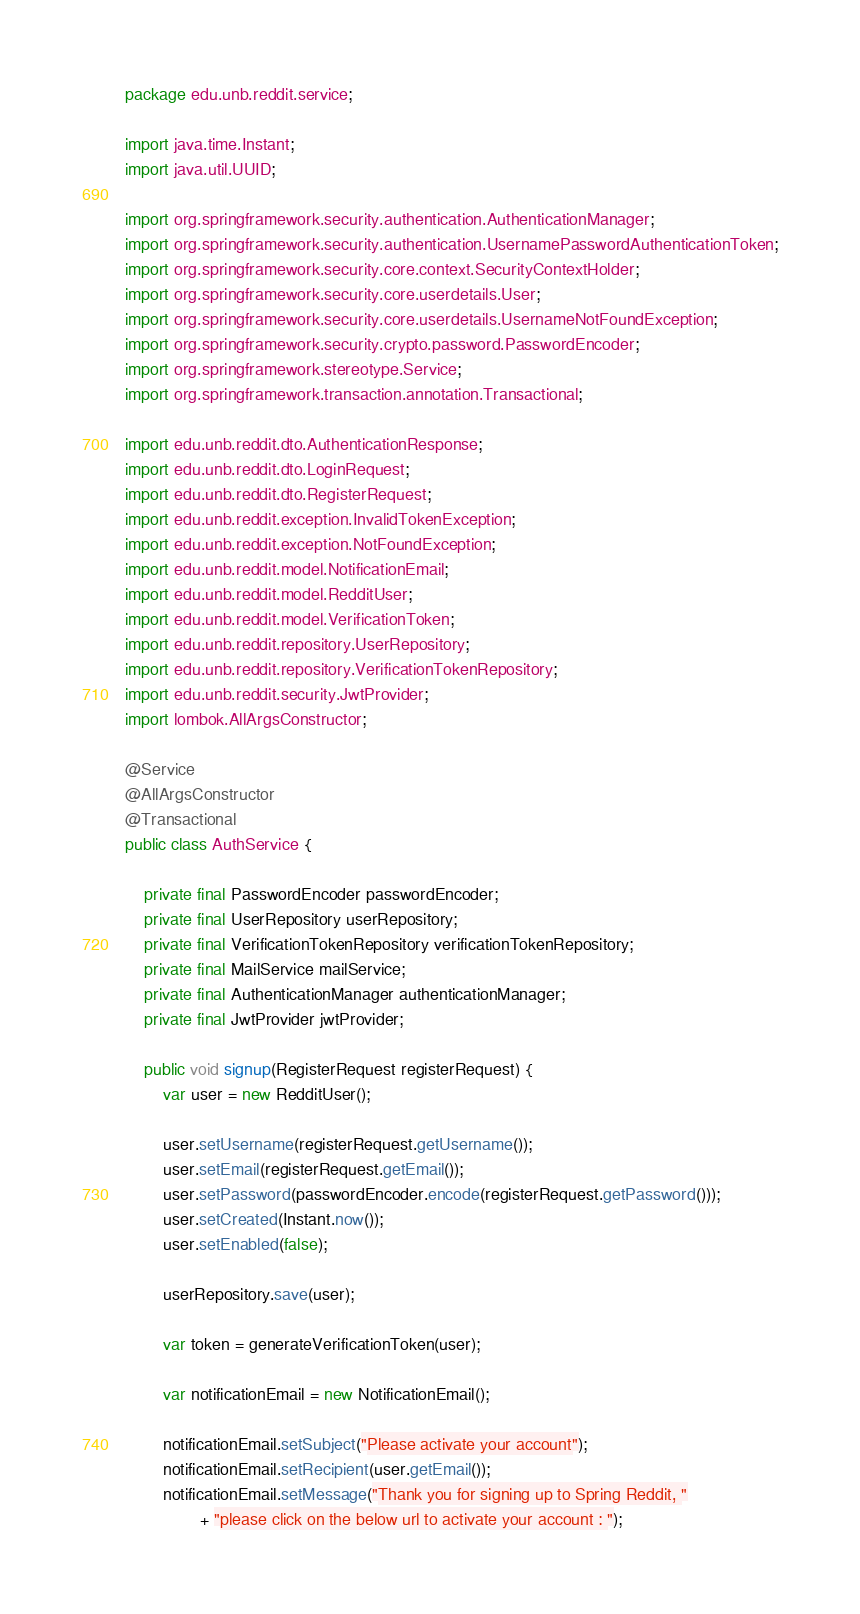Convert code to text. <code><loc_0><loc_0><loc_500><loc_500><_Java_>package edu.unb.reddit.service;

import java.time.Instant;
import java.util.UUID;

import org.springframework.security.authentication.AuthenticationManager;
import org.springframework.security.authentication.UsernamePasswordAuthenticationToken;
import org.springframework.security.core.context.SecurityContextHolder;
import org.springframework.security.core.userdetails.User;
import org.springframework.security.core.userdetails.UsernameNotFoundException;
import org.springframework.security.crypto.password.PasswordEncoder;
import org.springframework.stereotype.Service;
import org.springframework.transaction.annotation.Transactional;

import edu.unb.reddit.dto.AuthenticationResponse;
import edu.unb.reddit.dto.LoginRequest;
import edu.unb.reddit.dto.RegisterRequest;
import edu.unb.reddit.exception.InvalidTokenException;
import edu.unb.reddit.exception.NotFoundException;
import edu.unb.reddit.model.NotificationEmail;
import edu.unb.reddit.model.RedditUser;
import edu.unb.reddit.model.VerificationToken;
import edu.unb.reddit.repository.UserRepository;
import edu.unb.reddit.repository.VerificationTokenRepository;
import edu.unb.reddit.security.JwtProvider;
import lombok.AllArgsConstructor;

@Service
@AllArgsConstructor
@Transactional
public class AuthService {

	private final PasswordEncoder passwordEncoder;
	private final UserRepository userRepository;
	private final VerificationTokenRepository verificationTokenRepository;
	private final MailService mailService;
	private final AuthenticationManager authenticationManager;
	private final JwtProvider jwtProvider;

	public void signup(RegisterRequest registerRequest) {
		var user = new RedditUser();

		user.setUsername(registerRequest.getUsername());
		user.setEmail(registerRequest.getEmail());
		user.setPassword(passwordEncoder.encode(registerRequest.getPassword()));
		user.setCreated(Instant.now());
		user.setEnabled(false);

		userRepository.save(user);

		var token = generateVerificationToken(user);

		var notificationEmail = new NotificationEmail();

		notificationEmail.setSubject("Please activate your account");
		notificationEmail.setRecipient(user.getEmail());
		notificationEmail.setMessage("Thank you for signing up to Spring Reddit, "
				+ "please click on the below url to activate your account : ");</code> 